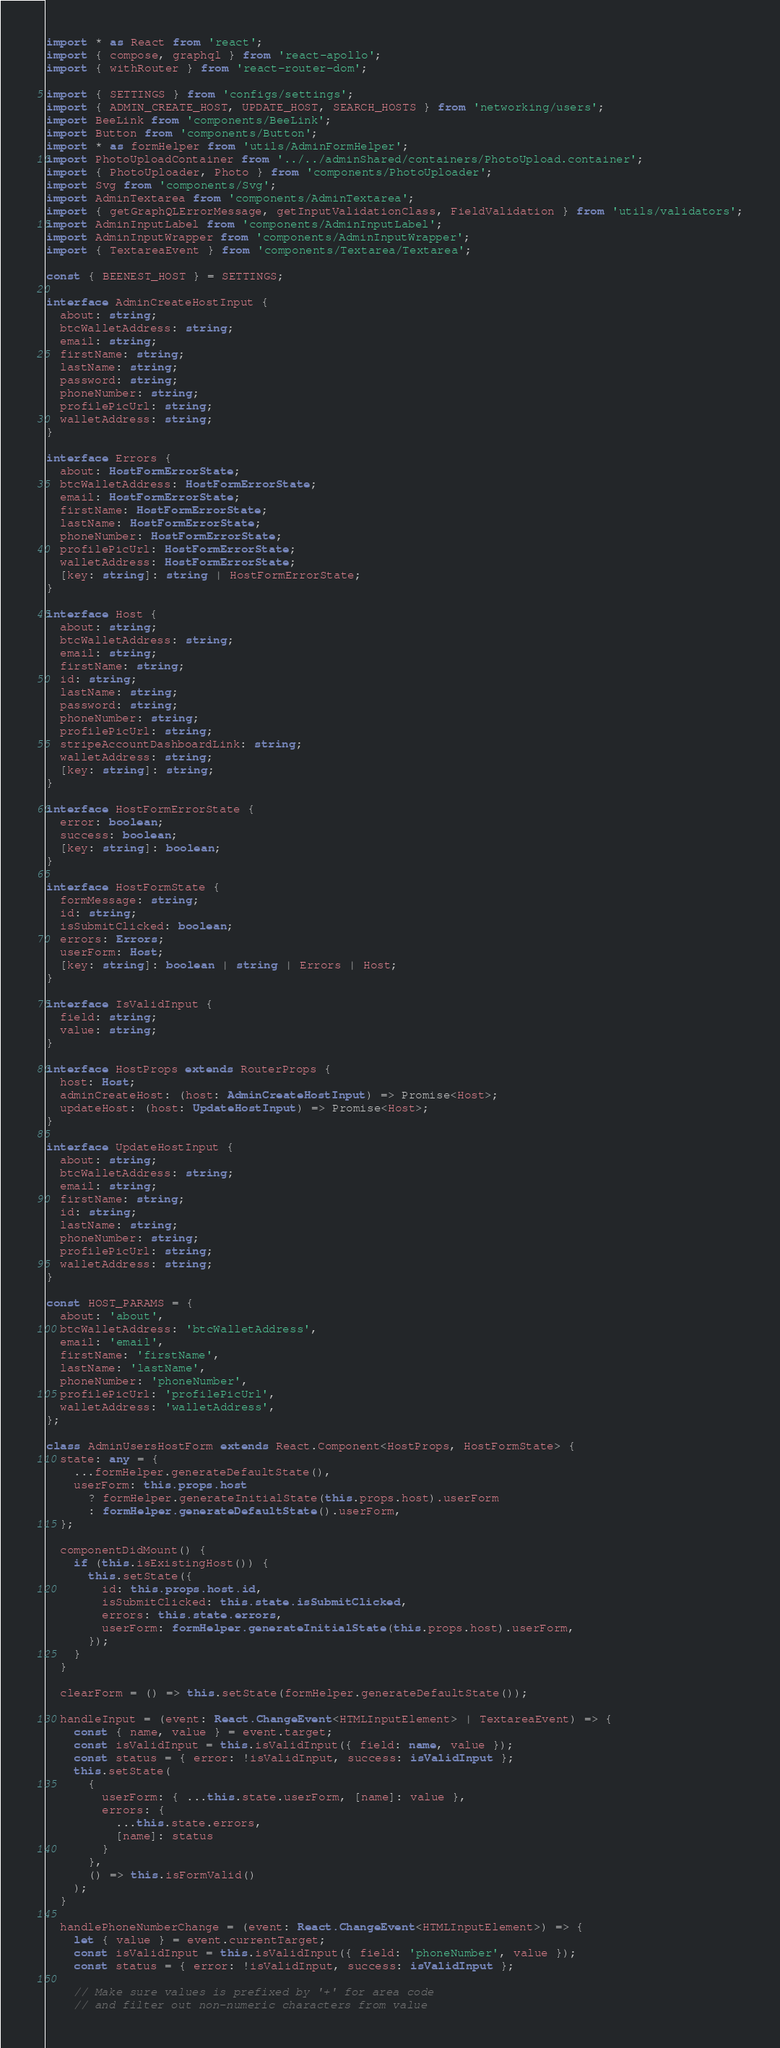<code> <loc_0><loc_0><loc_500><loc_500><_TypeScript_>import * as React from 'react';
import { compose, graphql } from 'react-apollo';
import { withRouter } from 'react-router-dom';

import { SETTINGS } from 'configs/settings';
import { ADMIN_CREATE_HOST, UPDATE_HOST, SEARCH_HOSTS } from 'networking/users';
import BeeLink from 'components/BeeLink';
import Button from 'components/Button';
import * as formHelper from 'utils/AdminFormHelper';
import PhotoUploadContainer from '../../adminShared/containers/PhotoUpload.container';
import { PhotoUploader, Photo } from 'components/PhotoUploader';
import Svg from 'components/Svg';
import AdminTextarea from 'components/AdminTextarea';
import { getGraphQLErrorMessage, getInputValidationClass, FieldValidation } from 'utils/validators';
import AdminInputLabel from 'components/AdminInputLabel';
import AdminInputWrapper from 'components/AdminInputWrapper';
import { TextareaEvent } from 'components/Textarea/Textarea';

const { BEENEST_HOST } = SETTINGS;

interface AdminCreateHostInput {
  about: string;
  btcWalletAddress: string;
  email: string;
  firstName: string;
  lastName: string;
  password: string;
  phoneNumber: string;
  profilePicUrl: string;
  walletAddress: string;
}

interface Errors {
  about: HostFormErrorState;
  btcWalletAddress: HostFormErrorState;
  email: HostFormErrorState;
  firstName: HostFormErrorState;
  lastName: HostFormErrorState;
  phoneNumber: HostFormErrorState;
  profilePicUrl: HostFormErrorState;
  walletAddress: HostFormErrorState;
  [key: string]: string | HostFormErrorState;
}

interface Host {
  about: string;
  btcWalletAddress: string;
  email: string;
  firstName: string;
  id: string;
  lastName: string;
  password: string;
  phoneNumber: string;
  profilePicUrl: string;
  stripeAccountDashboardLink: string;
  walletAddress: string;
  [key: string]: string;
}

interface HostFormErrorState {
  error: boolean;
  success: boolean;
  [key: string]: boolean;
}

interface HostFormState {
  formMessage: string;
  id: string;
  isSubmitClicked: boolean;
  errors: Errors;
  userForm: Host;
  [key: string]: boolean | string | Errors | Host;
}

interface IsValidInput {
  field: string;
  value: string;
}

interface HostProps extends RouterProps {
  host: Host;
  adminCreateHost: (host: AdminCreateHostInput) => Promise<Host>;
  updateHost: (host: UpdateHostInput) => Promise<Host>;
}

interface UpdateHostInput {
  about: string;
  btcWalletAddress: string;
  email: string;
  firstName: string;
  id: string;
  lastName: string;
  phoneNumber: string;
  profilePicUrl: string;
  walletAddress: string;
}

const HOST_PARAMS = {
  about: 'about',
  btcWalletAddress: 'btcWalletAddress',
  email: 'email',
  firstName: 'firstName',
  lastName: 'lastName',
  phoneNumber: 'phoneNumber',
  profilePicUrl: 'profilePicUrl',
  walletAddress: 'walletAddress',
};

class AdminUsersHostForm extends React.Component<HostProps, HostFormState> {
  state: any = {
    ...formHelper.generateDefaultState(),
    userForm: this.props.host
      ? formHelper.generateInitialState(this.props.host).userForm
      : formHelper.generateDefaultState().userForm,
  };

  componentDidMount() {
    if (this.isExistingHost()) {
      this.setState({
        id: this.props.host.id,
        isSubmitClicked: this.state.isSubmitClicked,
        errors: this.state.errors,
        userForm: formHelper.generateInitialState(this.props.host).userForm,
      });
    }
  }

  clearForm = () => this.setState(formHelper.generateDefaultState());

  handleInput = (event: React.ChangeEvent<HTMLInputElement> | TextareaEvent) => {
    const { name, value } = event.target;
    const isValidInput = this.isValidInput({ field: name, value });
    const status = { error: !isValidInput, success: isValidInput };
    this.setState(
      {
        userForm: { ...this.state.userForm, [name]: value },
        errors: {
          ...this.state.errors,
          [name]: status
        }
      },
      () => this.isFormValid()
    );
  }

  handlePhoneNumberChange = (event: React.ChangeEvent<HTMLInputElement>) => {
    let { value } = event.currentTarget;
    const isValidInput = this.isValidInput({ field: 'phoneNumber', value });
    const status = { error: !isValidInput, success: isValidInput };

    // Make sure values is prefixed by '+' for area code
    // and filter out non-numeric characters from value</code> 